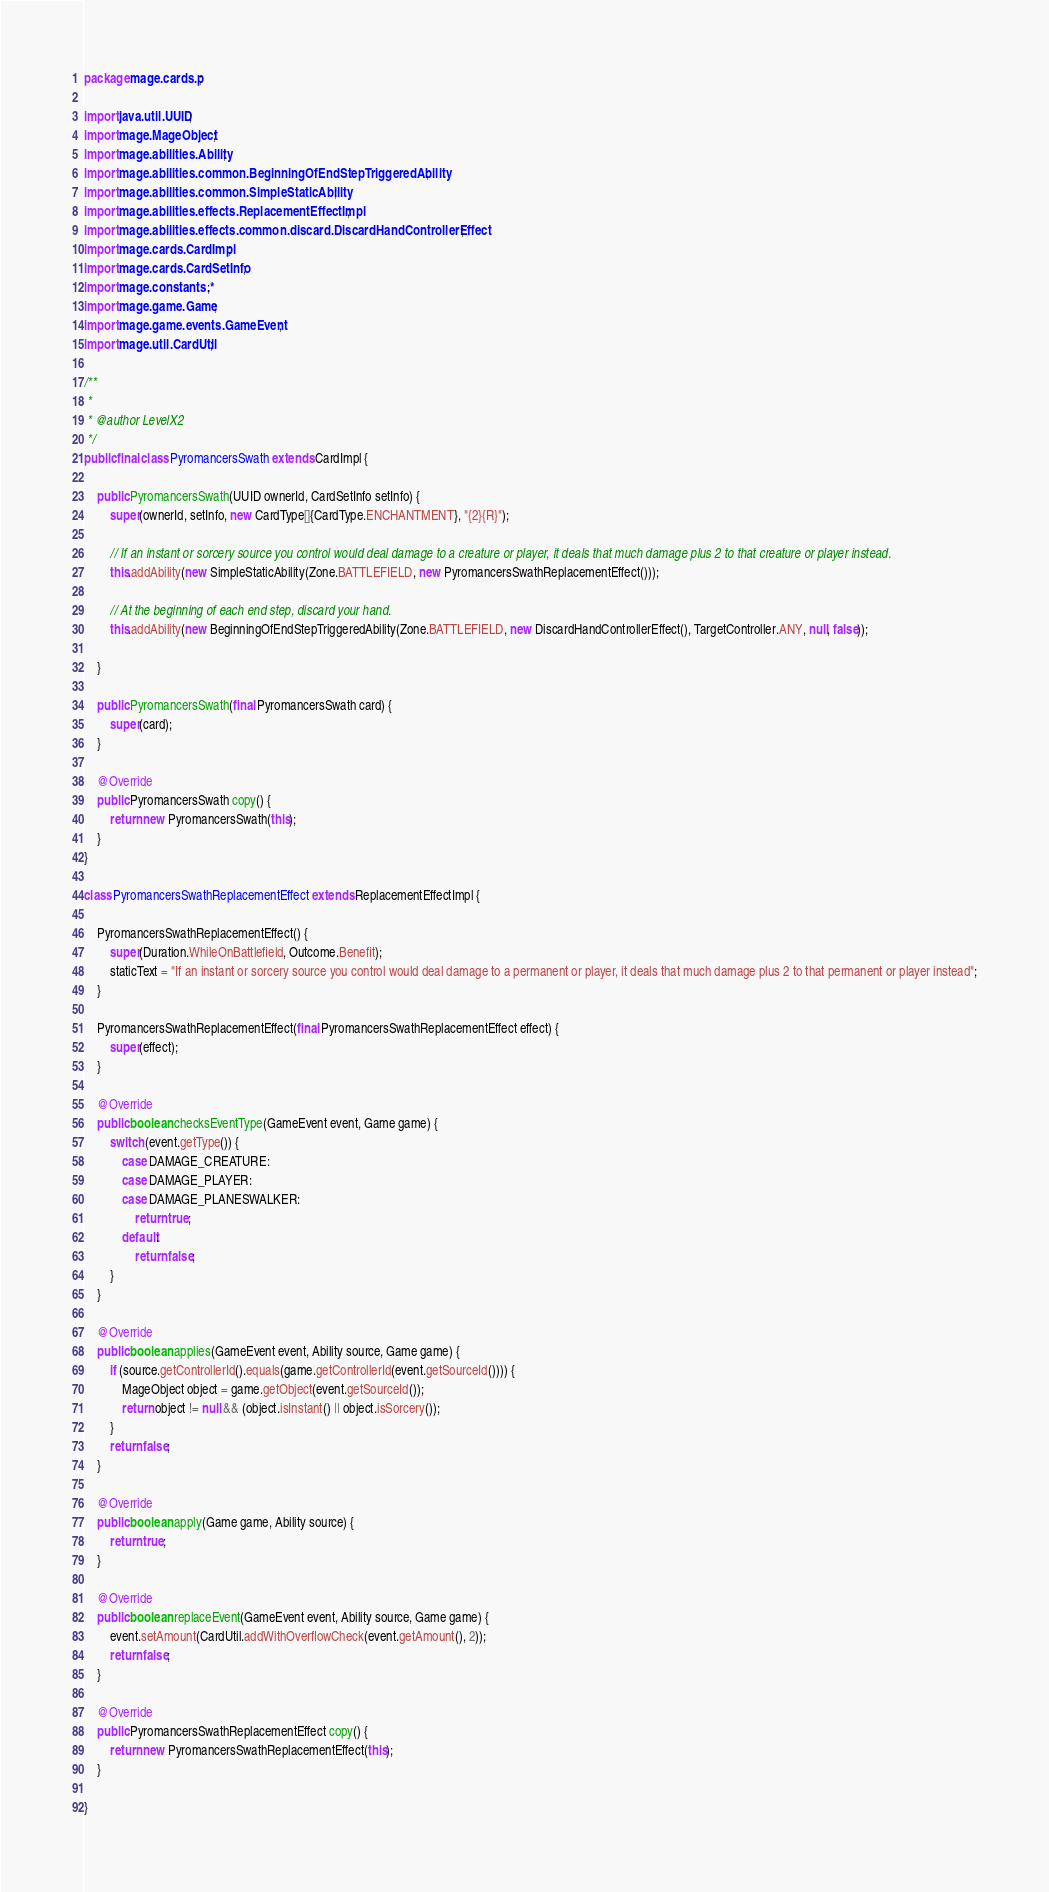Convert code to text. <code><loc_0><loc_0><loc_500><loc_500><_Java_>
package mage.cards.p;

import java.util.UUID;
import mage.MageObject;
import mage.abilities.Ability;
import mage.abilities.common.BeginningOfEndStepTriggeredAbility;
import mage.abilities.common.SimpleStaticAbility;
import mage.abilities.effects.ReplacementEffectImpl;
import mage.abilities.effects.common.discard.DiscardHandControllerEffect;
import mage.cards.CardImpl;
import mage.cards.CardSetInfo;
import mage.constants.*;
import mage.game.Game;
import mage.game.events.GameEvent;
import mage.util.CardUtil;

/**
 *
 * @author LevelX2
 */
public final class PyromancersSwath extends CardImpl {

    public PyromancersSwath(UUID ownerId, CardSetInfo setInfo) {
        super(ownerId, setInfo, new CardType[]{CardType.ENCHANTMENT}, "{2}{R}");

        // If an instant or sorcery source you control would deal damage to a creature or player, it deals that much damage plus 2 to that creature or player instead.
        this.addAbility(new SimpleStaticAbility(Zone.BATTLEFIELD, new PyromancersSwathReplacementEffect()));

        // At the beginning of each end step, discard your hand.
        this.addAbility(new BeginningOfEndStepTriggeredAbility(Zone.BATTLEFIELD, new DiscardHandControllerEffect(), TargetController.ANY, null, false));

    }

    public PyromancersSwath(final PyromancersSwath card) {
        super(card);
    }

    @Override
    public PyromancersSwath copy() {
        return new PyromancersSwath(this);
    }
}

class PyromancersSwathReplacementEffect extends ReplacementEffectImpl {

    PyromancersSwathReplacementEffect() {
        super(Duration.WhileOnBattlefield, Outcome.Benefit);
        staticText = "If an instant or sorcery source you control would deal damage to a permanent or player, it deals that much damage plus 2 to that permanent or player instead";
    }

    PyromancersSwathReplacementEffect(final PyromancersSwathReplacementEffect effect) {
        super(effect);
    }

    @Override
    public boolean checksEventType(GameEvent event, Game game) {
        switch (event.getType()) {
            case DAMAGE_CREATURE:
            case DAMAGE_PLAYER:
            case DAMAGE_PLANESWALKER:
                return true;
            default:
                return false;
        }
    }

    @Override
    public boolean applies(GameEvent event, Ability source, Game game) {
        if (source.getControllerId().equals(game.getControllerId(event.getSourceId()))) {
            MageObject object = game.getObject(event.getSourceId());
            return object != null && (object.isInstant() || object.isSorcery());
        }
        return false;
    }

    @Override
    public boolean apply(Game game, Ability source) {
        return true;
    }

    @Override
    public boolean replaceEvent(GameEvent event, Ability source, Game game) {
        event.setAmount(CardUtil.addWithOverflowCheck(event.getAmount(), 2));
        return false;
    }

    @Override
    public PyromancersSwathReplacementEffect copy() {
        return new PyromancersSwathReplacementEffect(this);
    }

}
</code> 